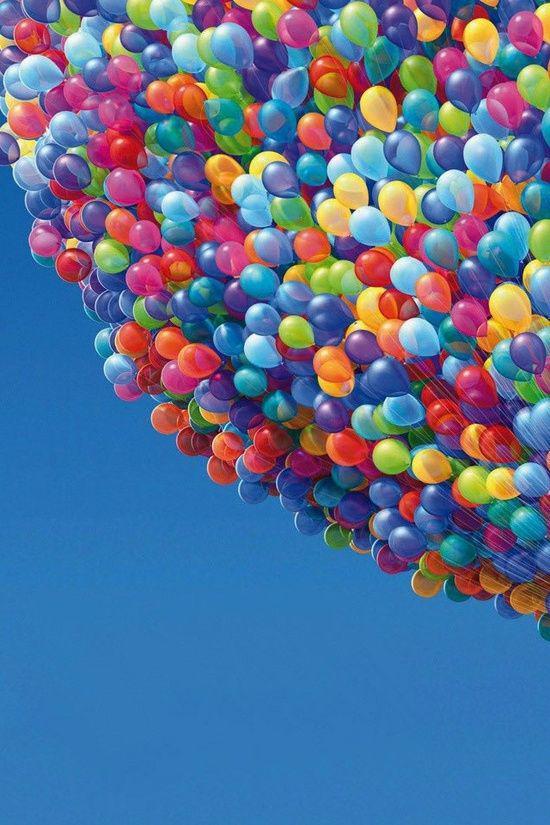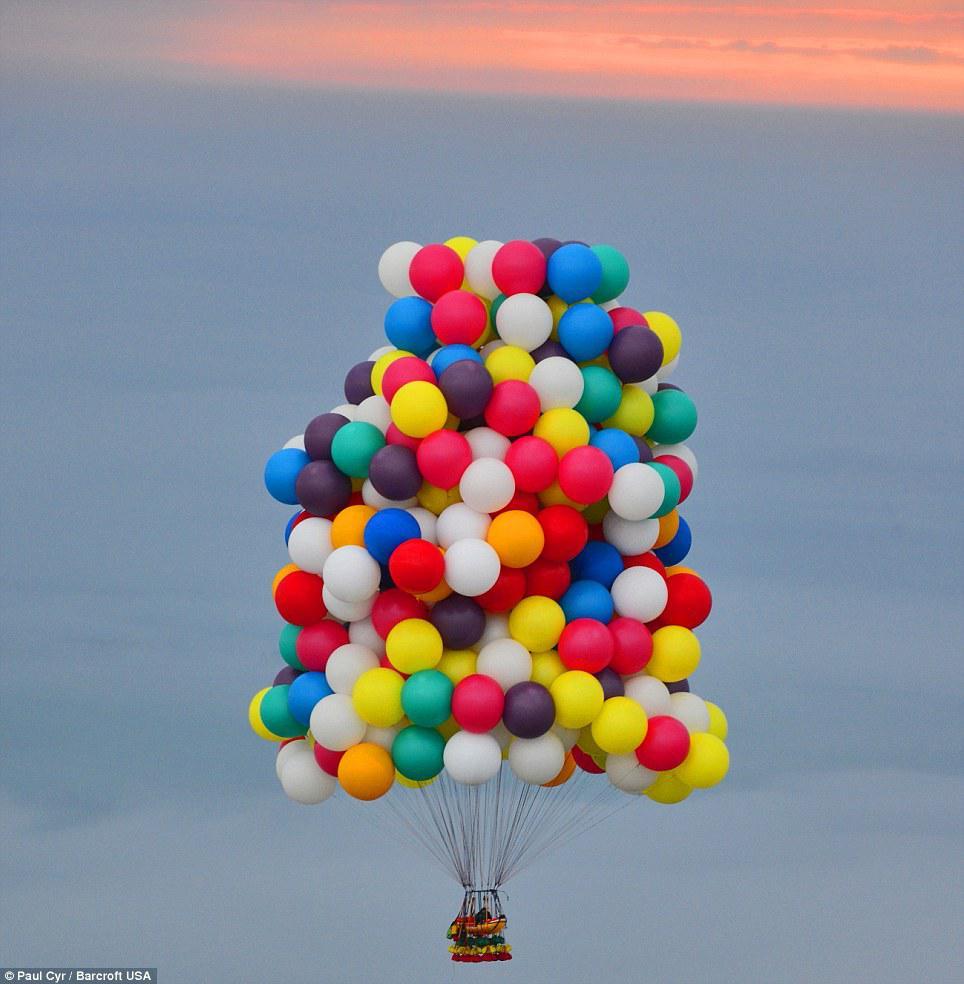The first image is the image on the left, the second image is the image on the right. For the images displayed, is the sentence "Balloons are carrying an object up in the air." factually correct? Answer yes or no. Yes. The first image is the image on the left, the second image is the image on the right. Assess this claim about the two images: "There is at least one person holding balloons.". Correct or not? Answer yes or no. No. 